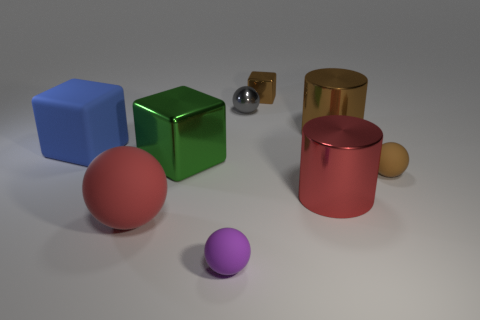Subtract 1 balls. How many balls are left? 3 Add 1 tiny brown rubber blocks. How many objects exist? 10 Subtract all blocks. How many objects are left? 6 Subtract 0 blue cylinders. How many objects are left? 9 Subtract all large red shiny spheres. Subtract all small purple things. How many objects are left? 8 Add 5 tiny spheres. How many tiny spheres are left? 8 Add 8 large green balls. How many large green balls exist? 8 